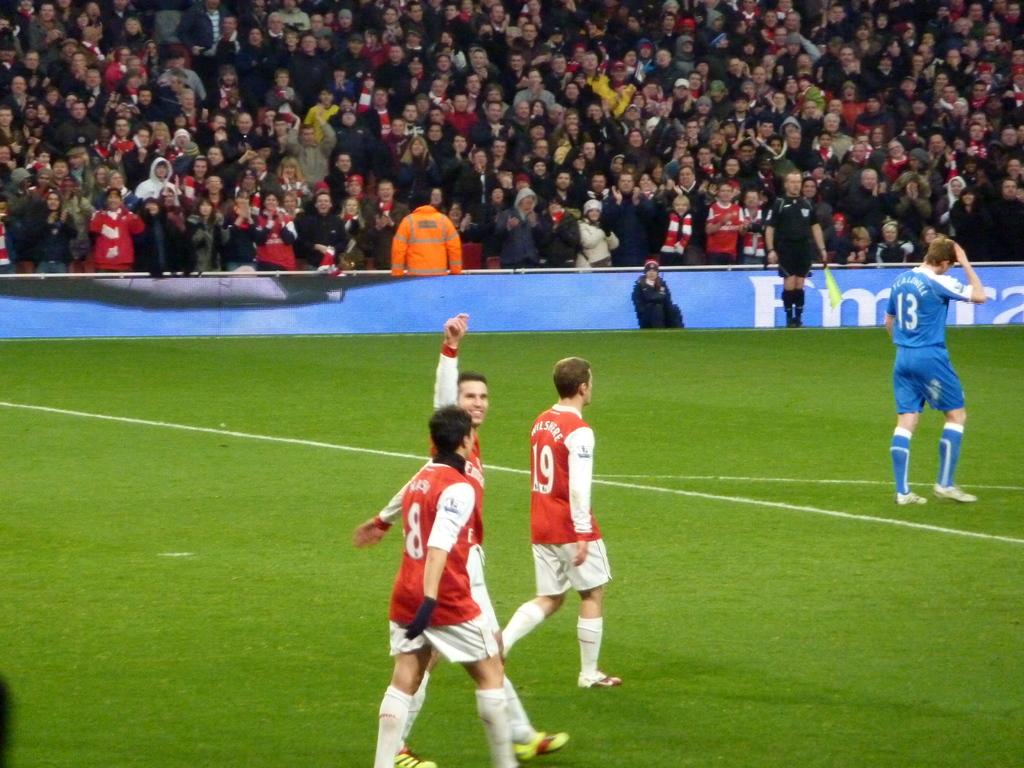<image>
Render a clear and concise summary of the photo. 3 red colored uniform soccer players with a player in blue uniform with the number 13 on his shirt. 